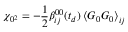<formula> <loc_0><loc_0><loc_500><loc_500>\chi _ { 0 ^ { 2 } } = - \frac { 1 } { 2 } \beta _ { i j } ^ { 0 0 } ( t _ { d } ) \left \langle G _ { 0 } G _ { 0 } \right \rangle _ { i j }</formula> 